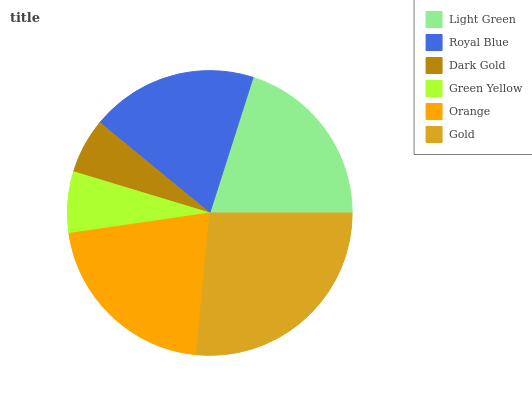Is Dark Gold the minimum?
Answer yes or no. Yes. Is Gold the maximum?
Answer yes or no. Yes. Is Royal Blue the minimum?
Answer yes or no. No. Is Royal Blue the maximum?
Answer yes or no. No. Is Light Green greater than Royal Blue?
Answer yes or no. Yes. Is Royal Blue less than Light Green?
Answer yes or no. Yes. Is Royal Blue greater than Light Green?
Answer yes or no. No. Is Light Green less than Royal Blue?
Answer yes or no. No. Is Light Green the high median?
Answer yes or no. Yes. Is Royal Blue the low median?
Answer yes or no. Yes. Is Dark Gold the high median?
Answer yes or no. No. Is Dark Gold the low median?
Answer yes or no. No. 